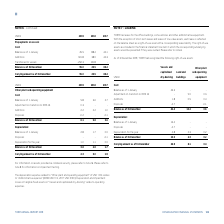According to Torm's financial document, What does TORM have leases for? the office buildings, some vehicles and other administrative equipment.. The document states: "NOTE 7 – LEASING TORM has leases for the office buildings, some vehicles and other administrative equipment. With the exception of short-term leases a..." Also, How is each lease reflected on the balance sheet? as a right-of-use asset with a corresponding lease liability. The right-of-use assets are included in the financial statement line item in which the corresponding underlying assets would be presented if they were owned.. The document states: "sets, each lease is reflected on the balance sheet as a right-of-use asset with a corresponding lease liability. The right-of-use assets are included ..." Also, What are the types of right-of-use assets considered in the table? The document contains multiple relevant values: Vessels and capitalized dry-docking, Land and buildings, Other plant and operating equipment. From the document: "Other plant and operating equipment nd impairment losses on tangible fixed assets on "Vessels and capitalized dry-docking" relate to operating expense..." Additionally, Which asset type has the largest depreciation of the year? Vessels and capitalized dry-docking. The document states: "nd impairment losses on tangible fixed assets on "Vessels and capitalized dry-docking" relate to operating expenses...." Also, can you calculate: What was the change in the depreciation balance as of 31 December from 1 January in 2019 for vessels and capitalized dry-docking? Based on the calculation: 15.5-13.4, the result is 2.1 (in millions). This is based on the information: "Balance as of 1 January 13.4 - - Balance as of 31 December 15.5 2.3 0.2..." The key data points involved are: 13.4, 15.5. Also, can you calculate: What was the percentage change in the depreciation balance as of 31 December from 1 January in 2019 for vessels and capitalized dry-docking? To answer this question, I need to perform calculations using the financial data. The calculation is: (15.5-13.4)/13.4, which equals 15.67 (percentage). This is based on the information: "Balance as of 1 January 13.4 - - Balance as of 31 December 15.5 2.3 0.2..." The key data points involved are: 13.4, 15.5. 